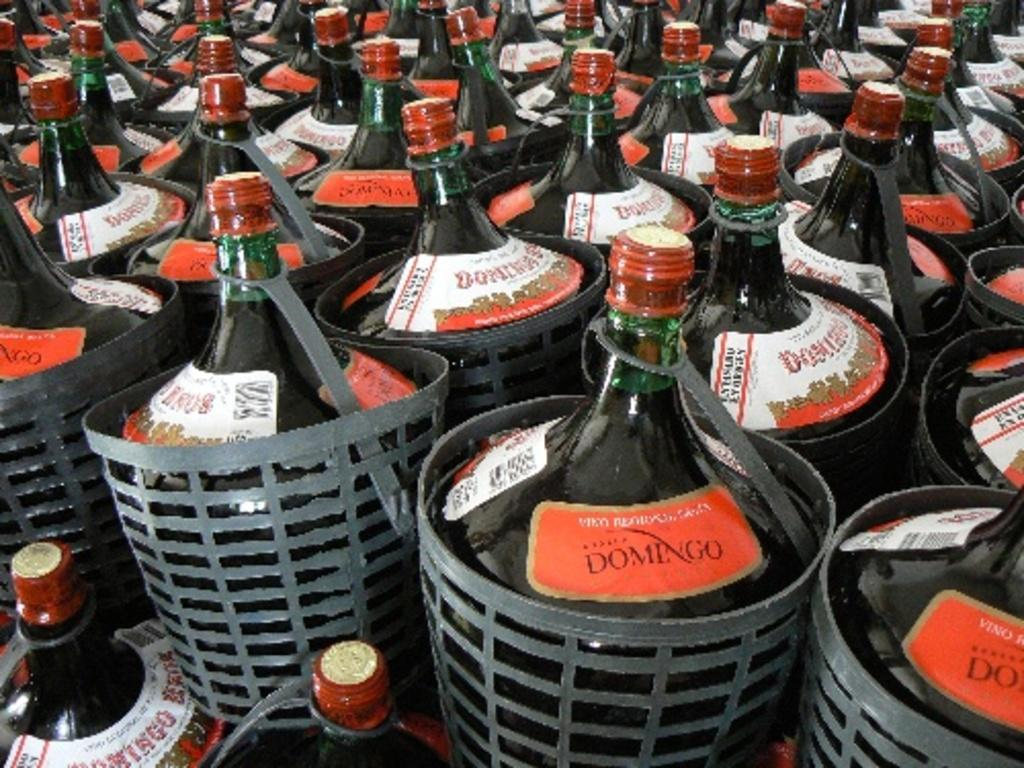<image>
Give a short and clear explanation of the subsequent image. very large bottles of domingo all in black baskets 